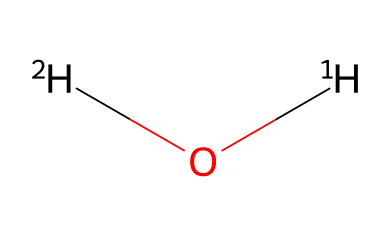What are the isotopes present in this water molecule? The chemical structure indicates two types of hydrogen atoms, specifically deuterium (2H) and protium (1H), which are the isotopes of hydrogen in the water molecule.
Answer: deuterium and protium How many hydrogen atoms are in this water molecule? The SMILES representation shows one [2H] and one [1H], which adds up to a total of two hydrogen atoms in the water molecule.
Answer: two How many oxygen atoms are present in this molecule? The structure indicates there is one [1H]O, meaning there is a single oxygen atom bonded to two hydrogen atoms.
Answer: one What is the chemical formula of this water molecule? Combining the identified isotopes, the molecule can be expressed as D2O where D represents deuterium and O represents oxygen.
Answer: D2O What type of chemical is represented by this structure? The presence of two hydrogen atoms bonded to an oxygen atom signifies that this is a water molecule, but due to the isotopes, it's a form of heavy water.
Answer: water (heavy water) What is the significance of isotopic analysis in this context? Isotopic analysis can provide insights into the physiological processes during performance, including hydration levels and metabolic reactions.
Answer: physiological insights 